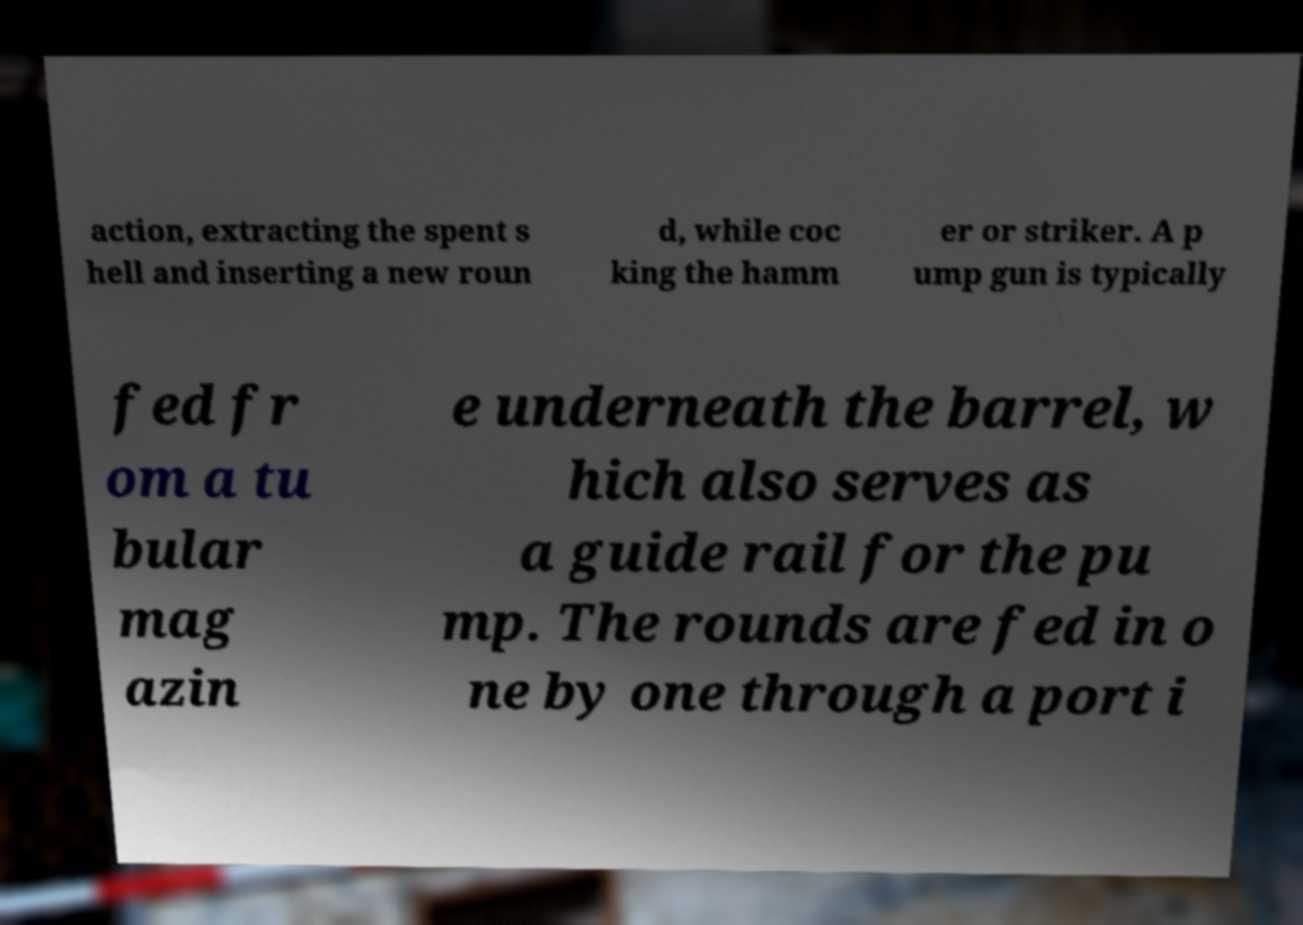Could you extract and type out the text from this image? action, extracting the spent s hell and inserting a new roun d, while coc king the hamm er or striker. A p ump gun is typically fed fr om a tu bular mag azin e underneath the barrel, w hich also serves as a guide rail for the pu mp. The rounds are fed in o ne by one through a port i 